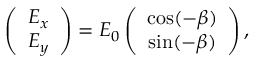Convert formula to latex. <formula><loc_0><loc_0><loc_500><loc_500>\begin{array} { r } { \left ( \begin{array} { c } { E _ { x } } \\ { E _ { y } } \end{array} \right ) = E _ { 0 } \left ( \begin{array} { c } { \cos ( - \beta ) } \\ { \sin ( - \beta ) } \end{array} \right ) , } \end{array}</formula> 